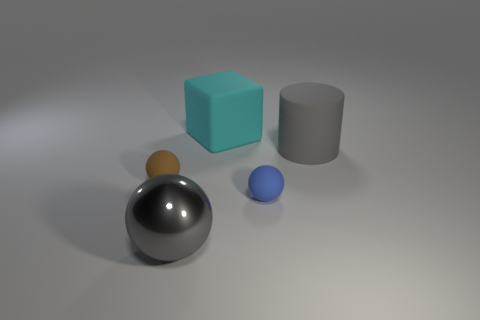Add 5 brown balls. How many objects exist? 10 Subtract all spheres. How many objects are left? 2 Subtract 1 cyan cubes. How many objects are left? 4 Subtract all large gray shiny things. Subtract all brown metal cylinders. How many objects are left? 4 Add 1 tiny brown balls. How many tiny brown balls are left? 2 Add 3 big blue balls. How many big blue balls exist? 3 